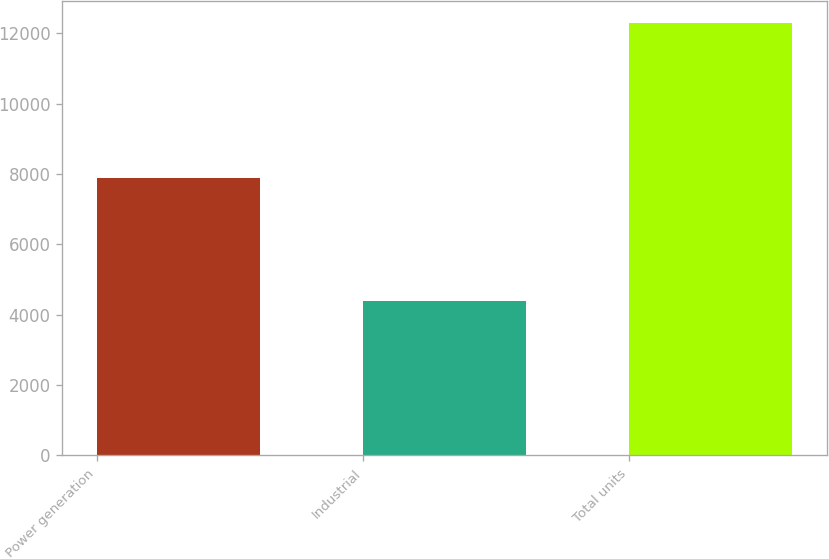Convert chart to OTSL. <chart><loc_0><loc_0><loc_500><loc_500><bar_chart><fcel>Power generation<fcel>Industrial<fcel>Total units<nl><fcel>7900<fcel>4400<fcel>12300<nl></chart> 